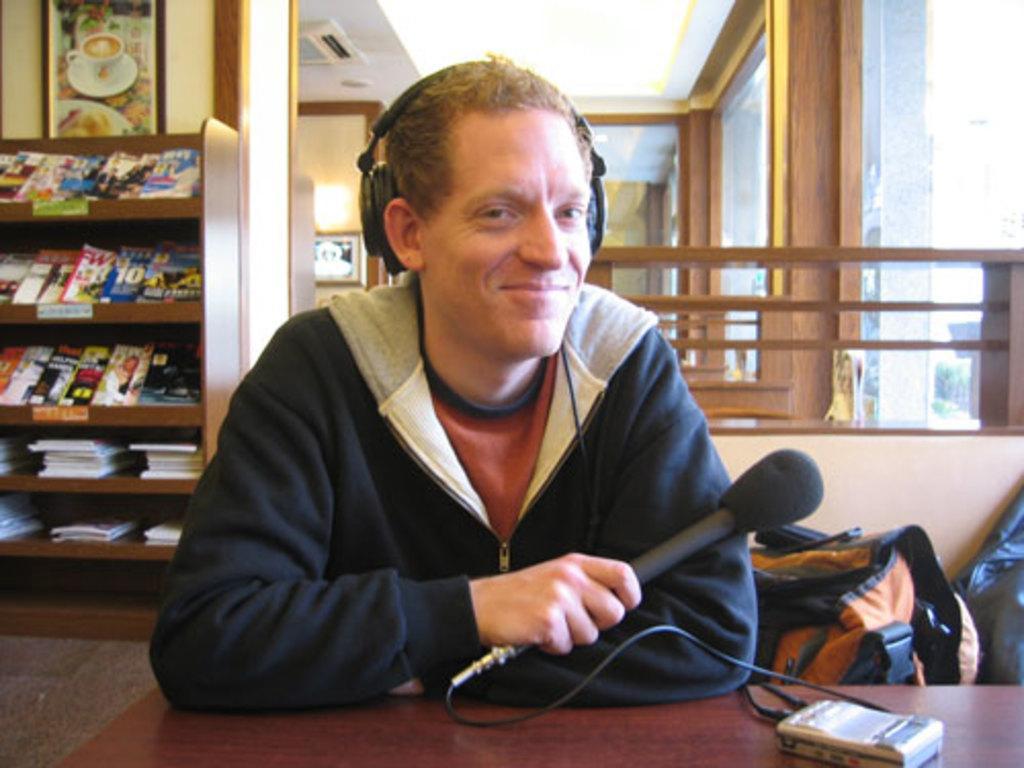Can you describe this image briefly? In this image we can see a person wearing blue color jacket holding microphone in his hands and also put his headphones on and there is receiver in front of him which is on the table and in the background of the image there are some books which are arranged in the shelves, there are some paintings attached to the wall, there is fencing and some glass doors, there are bags beside him. 